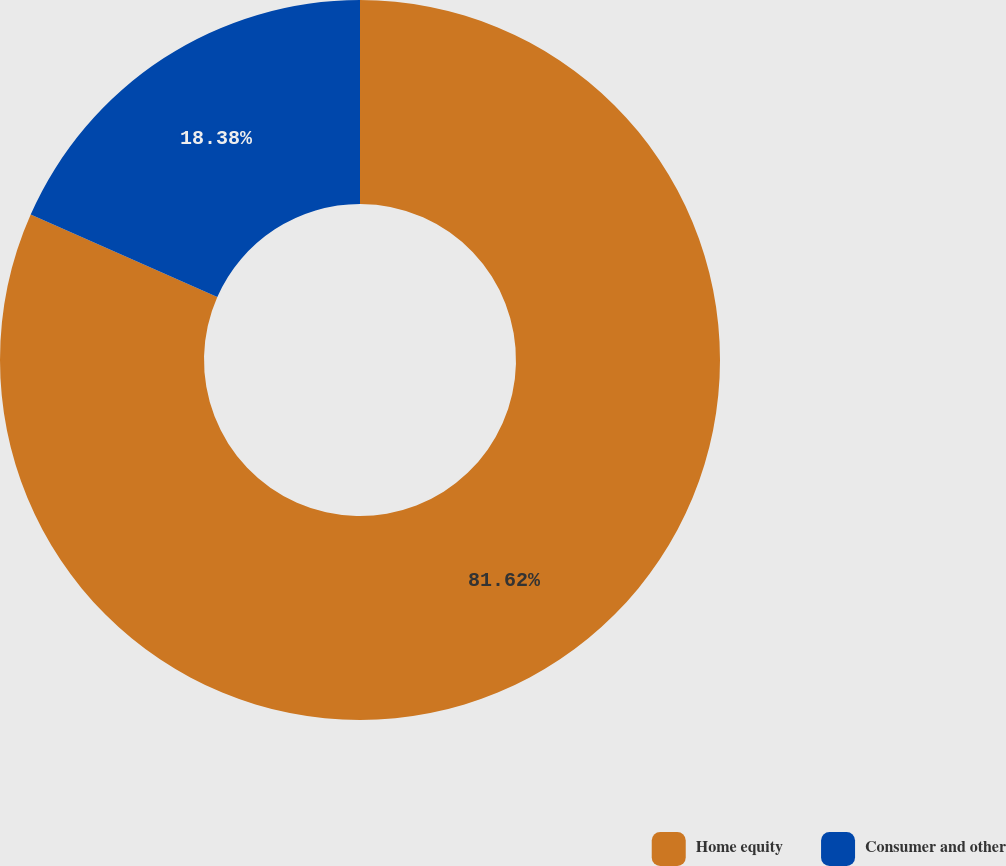Convert chart to OTSL. <chart><loc_0><loc_0><loc_500><loc_500><pie_chart><fcel>Home equity<fcel>Consumer and other<nl><fcel>81.62%<fcel>18.38%<nl></chart> 